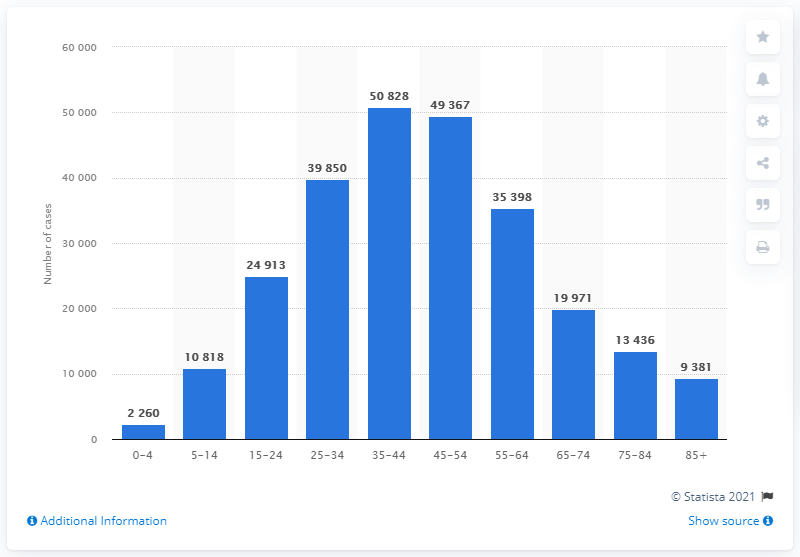Outline some significant characteristics in this image. The summation of the highest and lowest COVID-19 cases reported is 53,088. There have been 9381 confirmed cases of coronavirus in the 85+ age group in Slovenia in 2021. The age group with the highest number of infections is 35-44. 